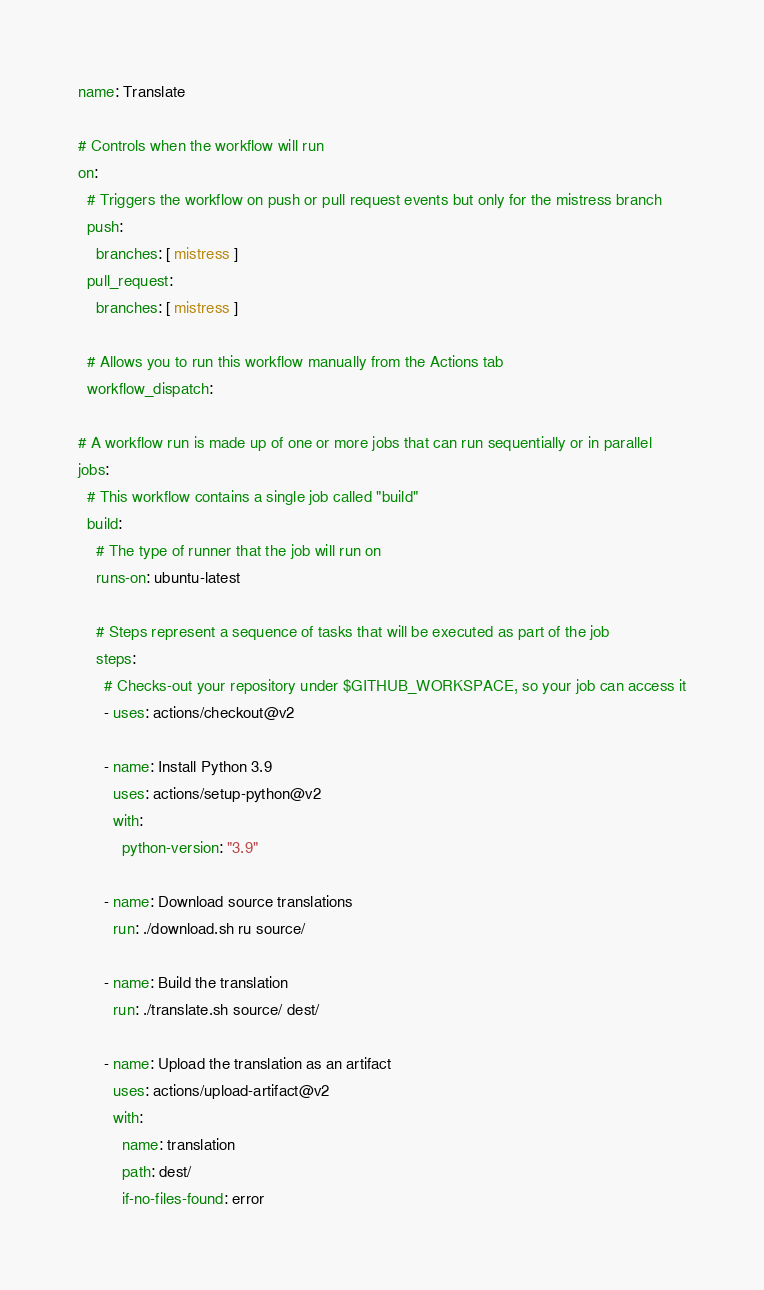Convert code to text. <code><loc_0><loc_0><loc_500><loc_500><_YAML_>name: Translate

# Controls when the workflow will run
on:
  # Triggers the workflow on push or pull request events but only for the mistress branch
  push:
    branches: [ mistress ]
  pull_request:
    branches: [ mistress ]

  # Allows you to run this workflow manually from the Actions tab
  workflow_dispatch:

# A workflow run is made up of one or more jobs that can run sequentially or in parallel
jobs:
  # This workflow contains a single job called "build"
  build:
    # The type of runner that the job will run on
    runs-on: ubuntu-latest

    # Steps represent a sequence of tasks that will be executed as part of the job
    steps:
      # Checks-out your repository under $GITHUB_WORKSPACE, so your job can access it
      - uses: actions/checkout@v2
      
      - name: Install Python 3.9
        uses: actions/setup-python@v2
        with:
          python-version: "3.9"

      - name: Download source translations
        run: ./download.sh ru source/

      - name: Build the translation
        run: ./translate.sh source/ dest/
        
      - name: Upload the translation as an artifact
        uses: actions/upload-artifact@v2
        with:
          name: translation
          path: dest/
          if-no-files-found: error
</code> 